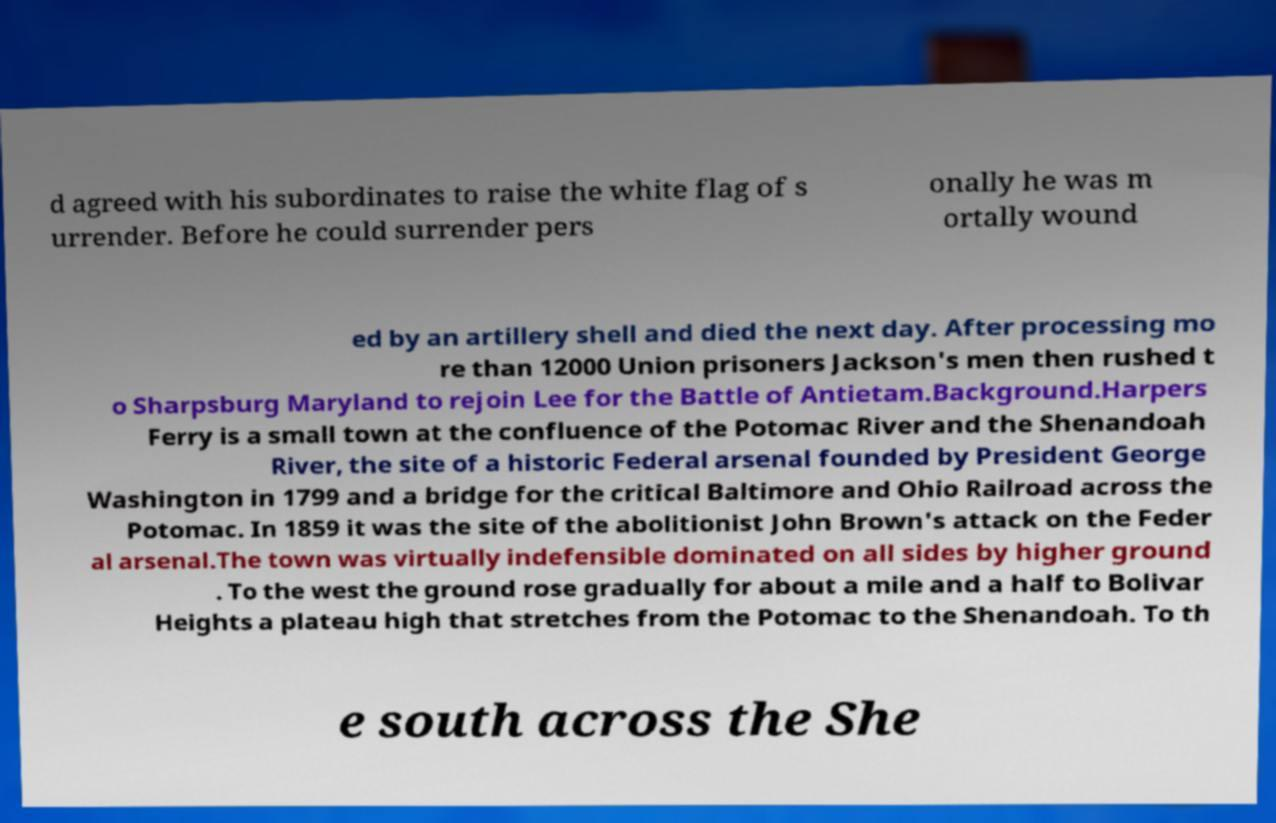Could you extract and type out the text from this image? d agreed with his subordinates to raise the white flag of s urrender. Before he could surrender pers onally he was m ortally wound ed by an artillery shell and died the next day. After processing mo re than 12000 Union prisoners Jackson's men then rushed t o Sharpsburg Maryland to rejoin Lee for the Battle of Antietam.Background.Harpers Ferry is a small town at the confluence of the Potomac River and the Shenandoah River, the site of a historic Federal arsenal founded by President George Washington in 1799 and a bridge for the critical Baltimore and Ohio Railroad across the Potomac. In 1859 it was the site of the abolitionist John Brown's attack on the Feder al arsenal.The town was virtually indefensible dominated on all sides by higher ground . To the west the ground rose gradually for about a mile and a half to Bolivar Heights a plateau high that stretches from the Potomac to the Shenandoah. To th e south across the She 